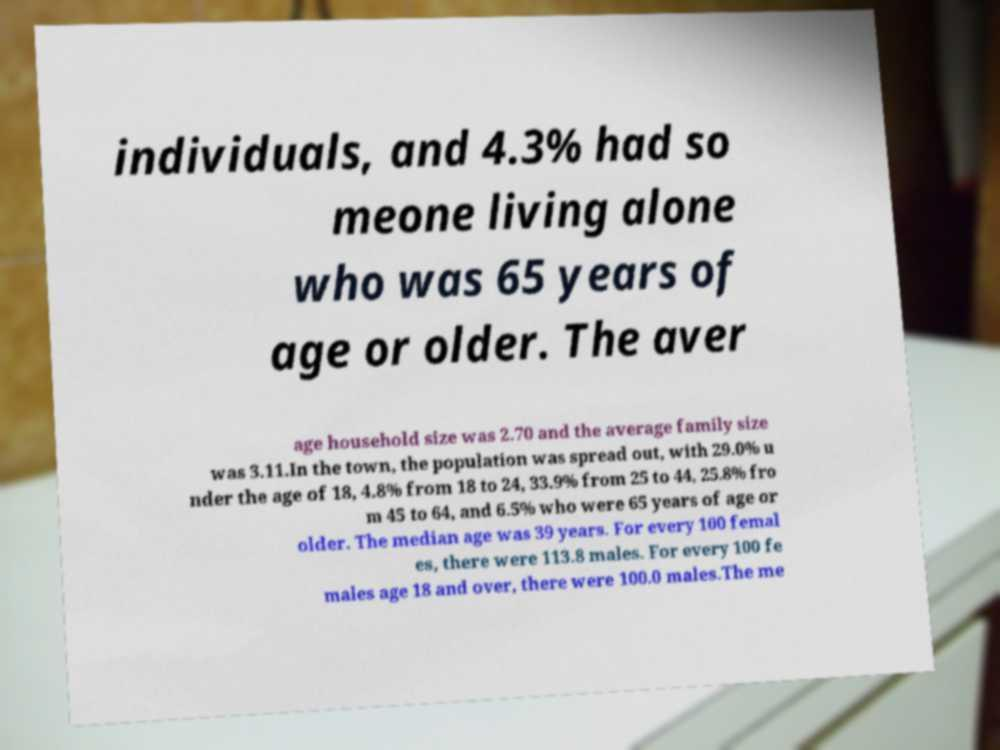For documentation purposes, I need the text within this image transcribed. Could you provide that? individuals, and 4.3% had so meone living alone who was 65 years of age or older. The aver age household size was 2.70 and the average family size was 3.11.In the town, the population was spread out, with 29.0% u nder the age of 18, 4.8% from 18 to 24, 33.9% from 25 to 44, 25.8% fro m 45 to 64, and 6.5% who were 65 years of age or older. The median age was 39 years. For every 100 femal es, there were 113.8 males. For every 100 fe males age 18 and over, there were 100.0 males.The me 